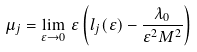<formula> <loc_0><loc_0><loc_500><loc_500>\mu _ { j } = \lim _ { \varepsilon \to 0 } \, \varepsilon \left ( l _ { j } ( \varepsilon ) - \frac { \lambda _ { 0 } } { \varepsilon ^ { 2 } M ^ { 2 } } \right )</formula> 